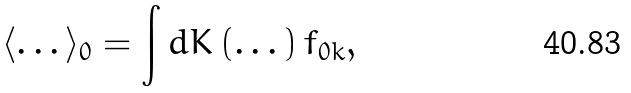Convert formula to latex. <formula><loc_0><loc_0><loc_500><loc_500>\langle \dots \rangle _ { 0 } = \int d K \left ( \dots \right ) f _ { 0 k } ,</formula> 